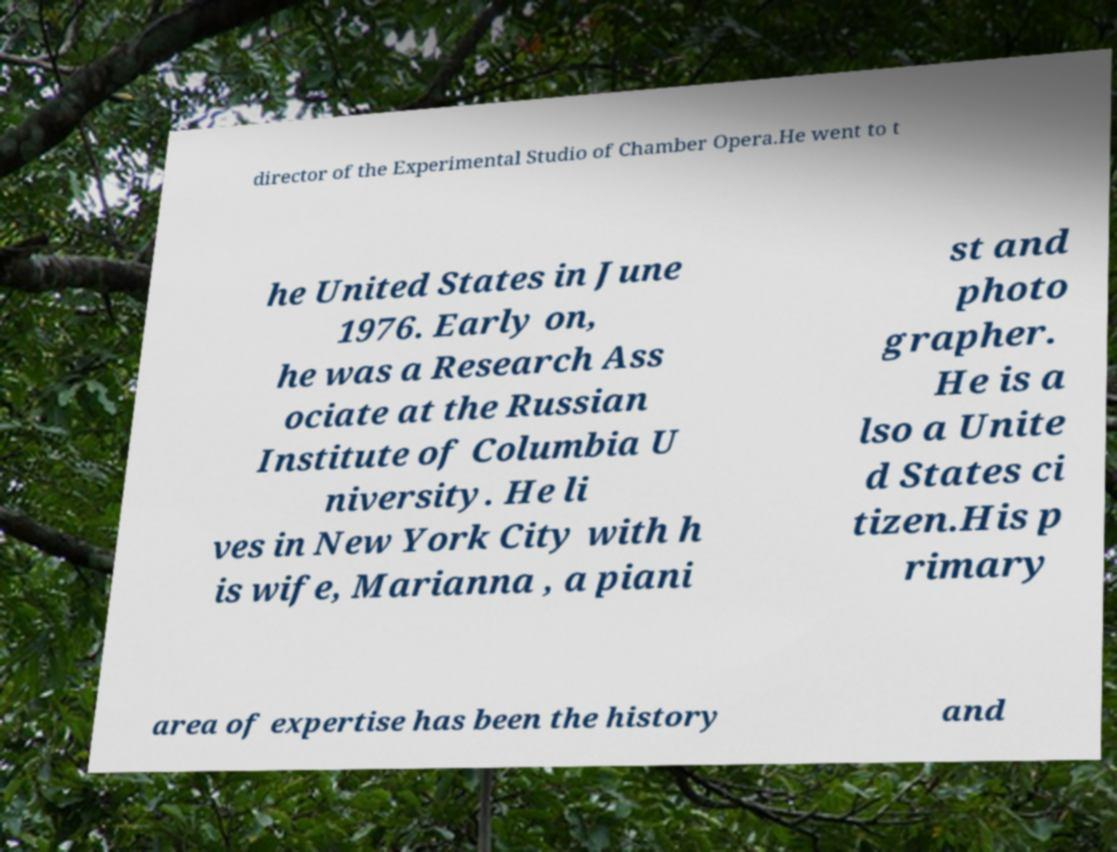Could you assist in decoding the text presented in this image and type it out clearly? director of the Experimental Studio of Chamber Opera.He went to t he United States in June 1976. Early on, he was a Research Ass ociate at the Russian Institute of Columbia U niversity. He li ves in New York City with h is wife, Marianna , a piani st and photo grapher. He is a lso a Unite d States ci tizen.His p rimary area of expertise has been the history and 